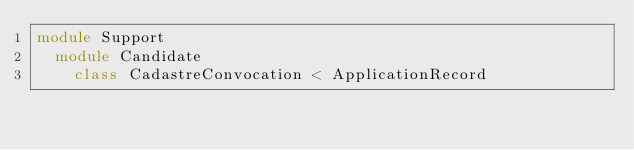<code> <loc_0><loc_0><loc_500><loc_500><_Ruby_>module Support
  module Candidate
    class CadastreConvocation < ApplicationRecord</code> 